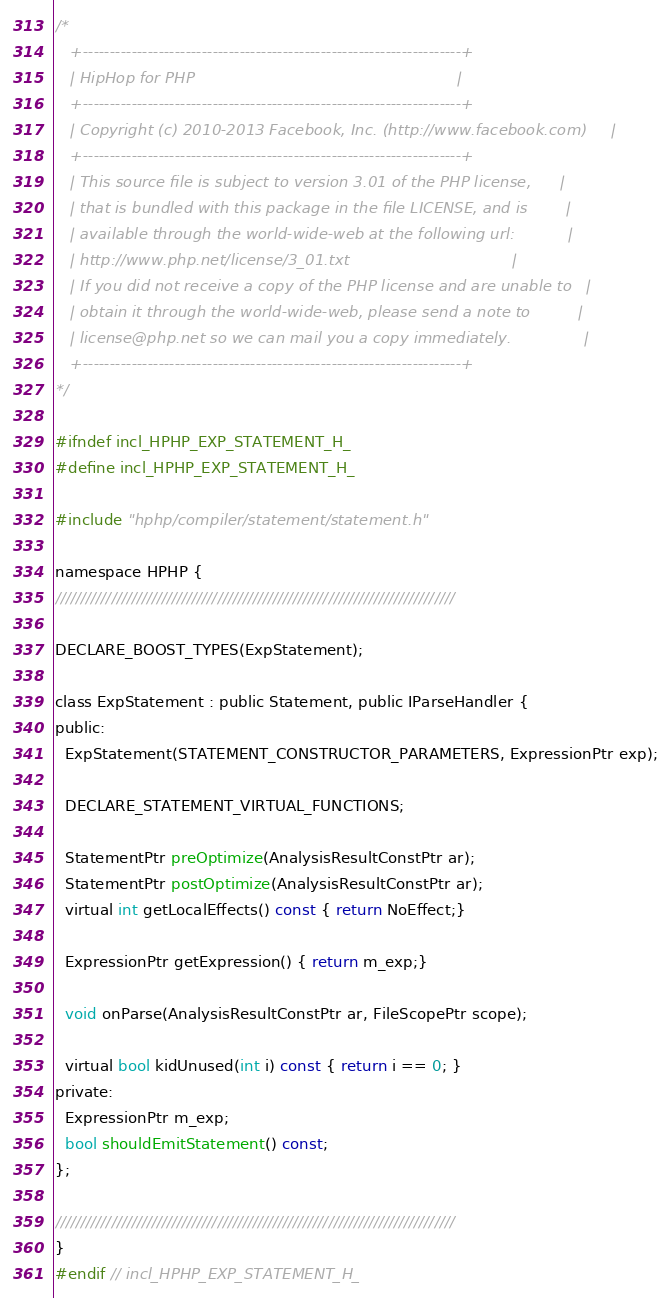<code> <loc_0><loc_0><loc_500><loc_500><_C_>/*
   +----------------------------------------------------------------------+
   | HipHop for PHP                                                       |
   +----------------------------------------------------------------------+
   | Copyright (c) 2010-2013 Facebook, Inc. (http://www.facebook.com)     |
   +----------------------------------------------------------------------+
   | This source file is subject to version 3.01 of the PHP license,      |
   | that is bundled with this package in the file LICENSE, and is        |
   | available through the world-wide-web at the following url:           |
   | http://www.php.net/license/3_01.txt                                  |
   | If you did not receive a copy of the PHP license and are unable to   |
   | obtain it through the world-wide-web, please send a note to          |
   | license@php.net so we can mail you a copy immediately.               |
   +----------------------------------------------------------------------+
*/

#ifndef incl_HPHP_EXP_STATEMENT_H_
#define incl_HPHP_EXP_STATEMENT_H_

#include "hphp/compiler/statement/statement.h"

namespace HPHP {
///////////////////////////////////////////////////////////////////////////////

DECLARE_BOOST_TYPES(ExpStatement);

class ExpStatement : public Statement, public IParseHandler {
public:
  ExpStatement(STATEMENT_CONSTRUCTOR_PARAMETERS, ExpressionPtr exp);

  DECLARE_STATEMENT_VIRTUAL_FUNCTIONS;

  StatementPtr preOptimize(AnalysisResultConstPtr ar);
  StatementPtr postOptimize(AnalysisResultConstPtr ar);
  virtual int getLocalEffects() const { return NoEffect;}

  ExpressionPtr getExpression() { return m_exp;}

  void onParse(AnalysisResultConstPtr ar, FileScopePtr scope);

  virtual bool kidUnused(int i) const { return i == 0; }
private:
  ExpressionPtr m_exp;
  bool shouldEmitStatement() const;
};

///////////////////////////////////////////////////////////////////////////////
}
#endif // incl_HPHP_EXP_STATEMENT_H_
</code> 